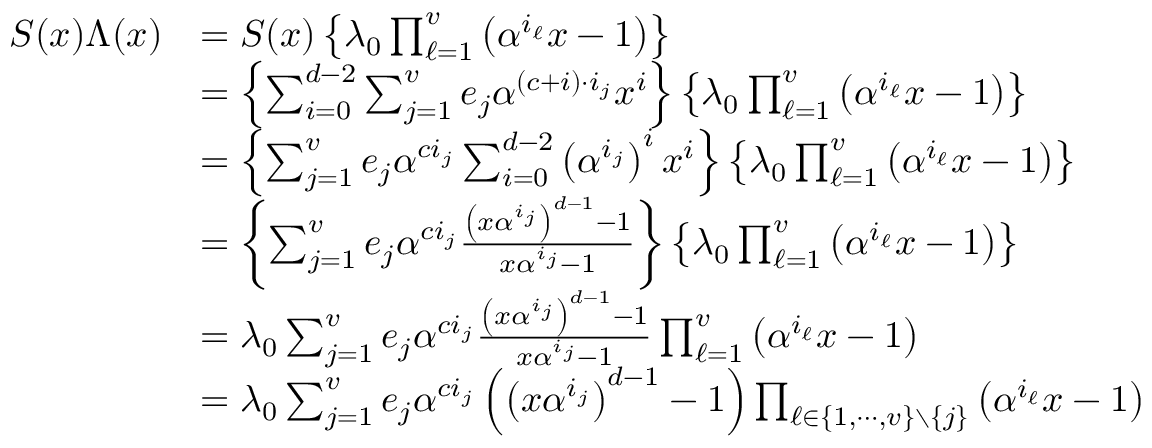<formula> <loc_0><loc_0><loc_500><loc_500>{ \begin{array} { r l } { S ( x ) \Lambda ( x ) } & { = S ( x ) \left \{ \lambda _ { 0 } \prod _ { \ell = 1 } ^ { v } \left ( \alpha ^ { i _ { \ell } } x - 1 \right ) \right \} } \\ & { = \left \{ \sum _ { i = 0 } ^ { d - 2 } \sum _ { j = 1 } ^ { v } e _ { j } \alpha ^ { ( c + i ) \cdot i _ { j } } x ^ { i } \right \} \left \{ \lambda _ { 0 } \prod _ { \ell = 1 } ^ { v } \left ( \alpha ^ { i _ { \ell } } x - 1 \right ) \right \} } \\ & { = \left \{ \sum _ { j = 1 } ^ { v } e _ { j } \alpha ^ { c i _ { j } } \sum _ { i = 0 } ^ { d - 2 } \left ( \alpha ^ { i _ { j } } \right ) ^ { i } x ^ { i } \right \} \left \{ \lambda _ { 0 } \prod _ { \ell = 1 } ^ { v } \left ( \alpha ^ { i _ { \ell } } x - 1 \right ) \right \} } \\ & { = \left \{ \sum _ { j = 1 } ^ { v } e _ { j } \alpha ^ { c i _ { j } } { \frac { \left ( x \alpha ^ { i _ { j } } \right ) ^ { d - 1 } - 1 } { x \alpha ^ { i _ { j } } - 1 } } \right \} \left \{ \lambda _ { 0 } \prod _ { \ell = 1 } ^ { v } \left ( \alpha ^ { i _ { \ell } } x - 1 \right ) \right \} } \\ & { = \lambda _ { 0 } \sum _ { j = 1 } ^ { v } e _ { j } \alpha ^ { c i _ { j } } { \frac { \left ( x \alpha ^ { i _ { j } } \right ) ^ { d - 1 } - 1 } { x \alpha ^ { i _ { j } } - 1 } } \prod _ { \ell = 1 } ^ { v } \left ( \alpha ^ { i _ { \ell } } x - 1 \right ) } \\ & { = \lambda _ { 0 } \sum _ { j = 1 } ^ { v } e _ { j } \alpha ^ { c i _ { j } } \left ( \left ( x \alpha ^ { i _ { j } } \right ) ^ { d - 1 } - 1 \right ) \prod _ { \ell \in \{ 1 , \cdots , v \} \ \{ j \} } \left ( \alpha ^ { i _ { \ell } } x - 1 \right ) } \end{array} }</formula> 